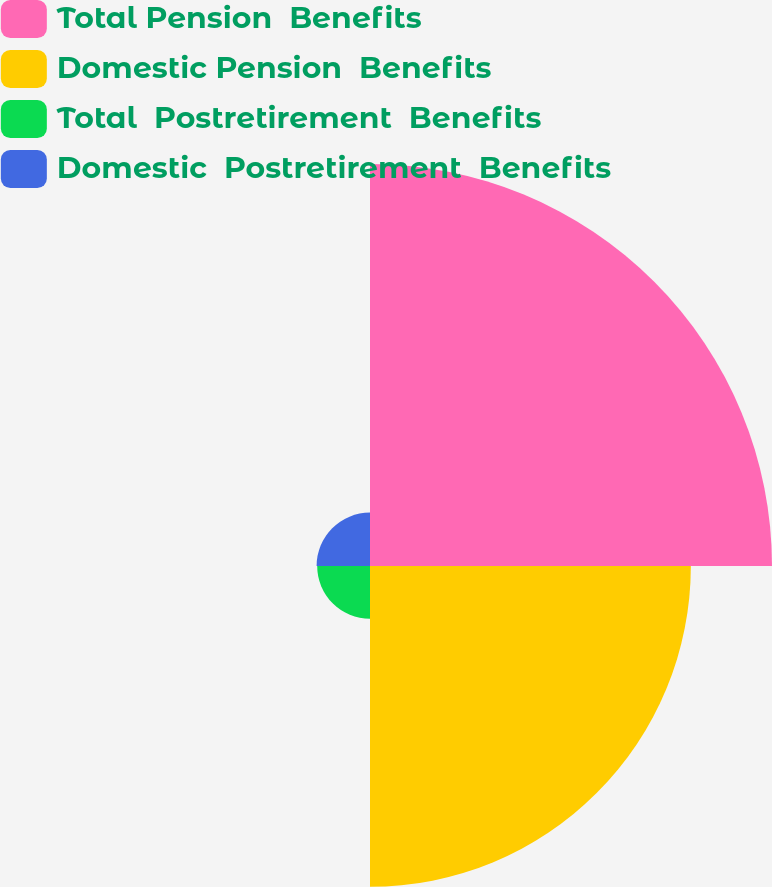Convert chart to OTSL. <chart><loc_0><loc_0><loc_500><loc_500><pie_chart><fcel>Total Pension  Benefits<fcel>Domestic Pension  Benefits<fcel>Total  Postretirement  Benefits<fcel>Domestic  Postretirement  Benefits<nl><fcel>48.49%<fcel>38.7%<fcel>6.37%<fcel>6.44%<nl></chart> 